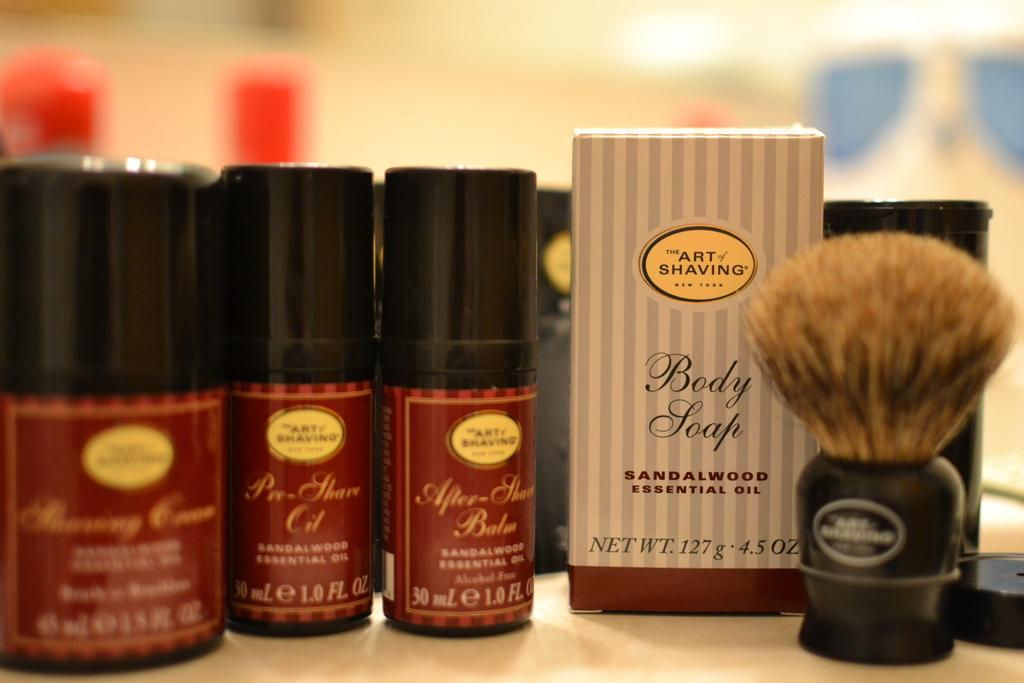<image>
Describe the image concisely. Various products from The Art Of Shaving sit on a table. 